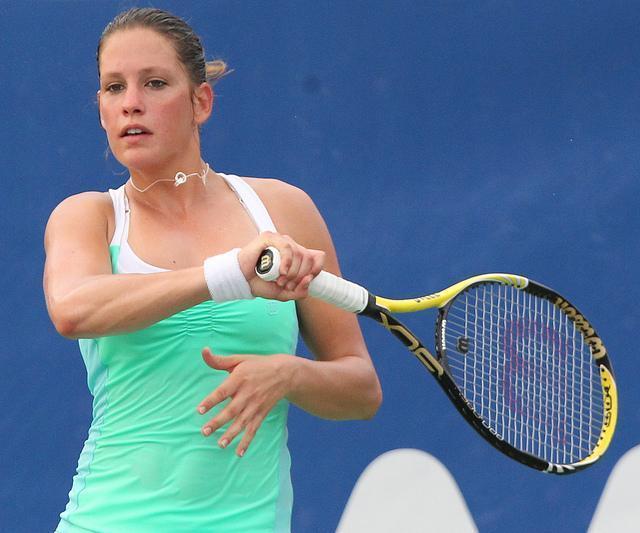How many giraffes are there?
Give a very brief answer. 0. 